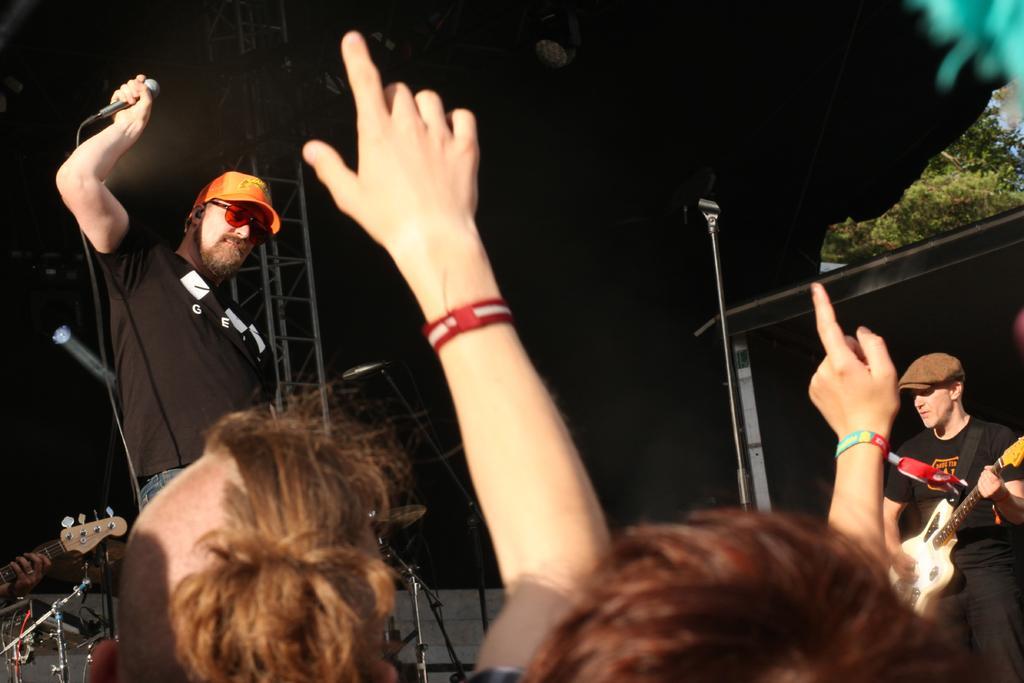Could you give a brief overview of what you see in this image? In this picture we can see man wore cap, goggle holding mic in his hand and beside to him other man holding guitar in his hand and playing it and in front of him we can see some persons and in background we can see pillar, light and it is dark. 